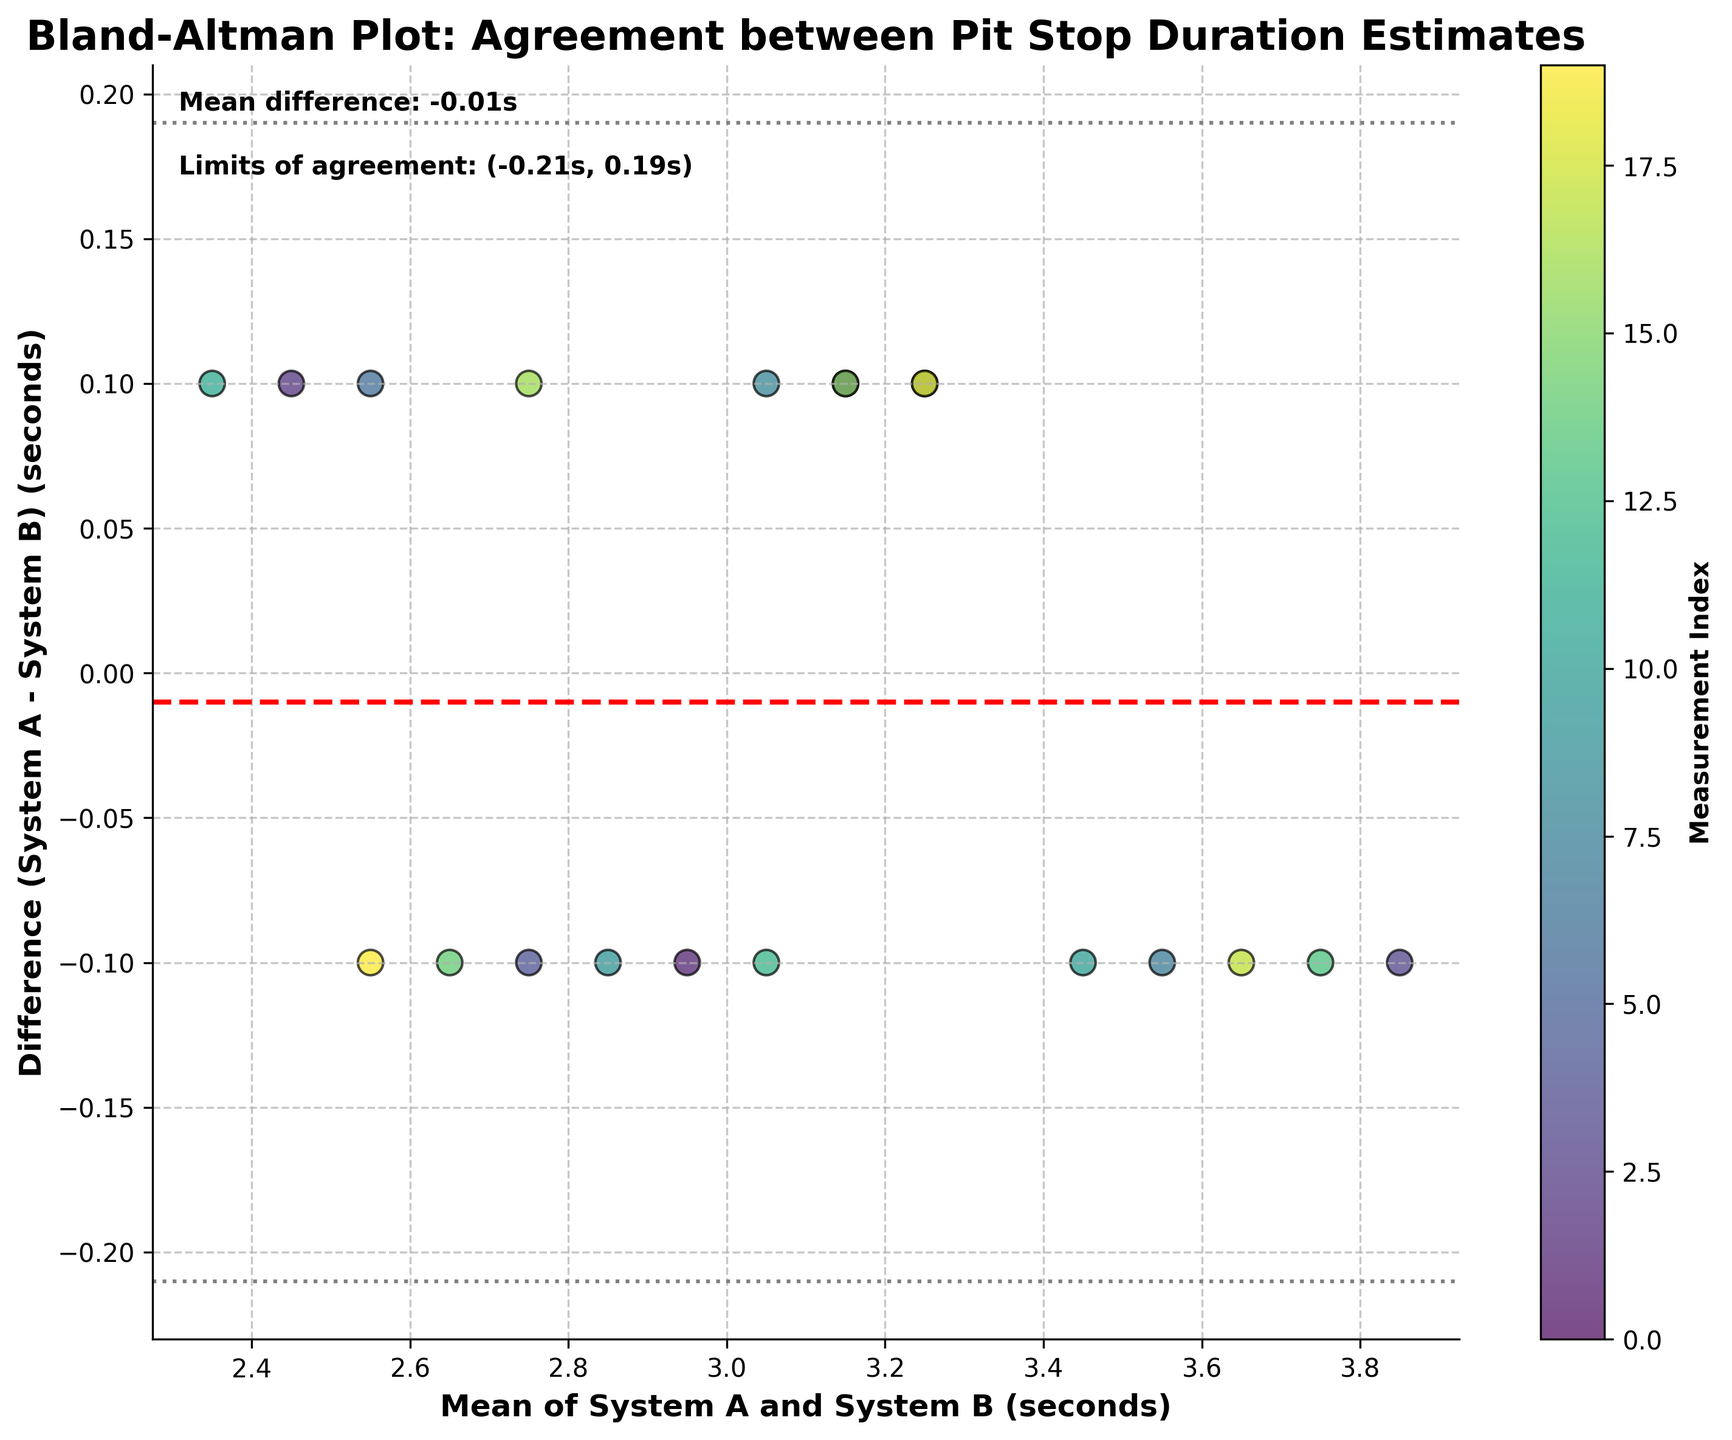What is the title of the figure? The title is displayed at the top of the figure and it reads "Bland-Altman Plot: Agreement between Pit Stop Duration Estimates".
Answer: Bland-Altman Plot: Agreement between Pit Stop Duration Estimates How many data points are shown in the plot? There are 10 teams, each with two data points. The plot shows one point per team representing the mean and difference of their pit stop times across two systems, totalling 20 data points.
Answer: 20 What do the gray horizontal lines represent in the plot? The gray horizontal lines represent the limits of agreement, which are calculated as mean difference ± 1.96 times the standard deviation of the differences.
Answer: Limits of agreement Is there any data point where System A consistently overestimates pit stop duration compared to System B? By checking the data points above the zero line, we see multiple points, indicating instances where System A overestimated the durations compared to System B.
Answer: Yes What is the approximate mean difference between System A and System B? The mean difference line is marked by a red dashed line near the y-axis and is also labeled with the exact value. It shows the average difference between the two systems.
Answer: Approximately 0 seconds How many teams have a mean pit stop duration of around 3 seconds? By scanning the x-axis for mean values around 3 seconds and counting the corresponding points, we can see that there are multiple data points in this range.
Answer: Multiple teams, around 3-5 Which teams' data points fall closest to the upper limit of agreement? The upper limit of agreement is shown as a gray dashed line. Checking which data points are closest to this line will give us the corresponding teams.
Answer: McLaren and Alfa Romeo What does it mean if a data point lies on the red dashed line? The red dashed line represents the mean difference between System A and System B. If a data point lies on this line, it means that the pit stop durations estimated by the two systems are on average the same.
Answer: Equal on average What color represents the data points in the plot and what does it indicate? The plot uses a color scheme called 'viridis', with brighter colors typically representing higher values or indices. Each data point's color represents its index within the dataset.
Answer: Various colors from the viridis color map What is the range of differences between the two systems? The y-axis represents the difference between System A and System B. Observing the spread of the data points can help identify the smallest and largest differences.
Answer: Approximately -0.2 to 0.2 seconds 